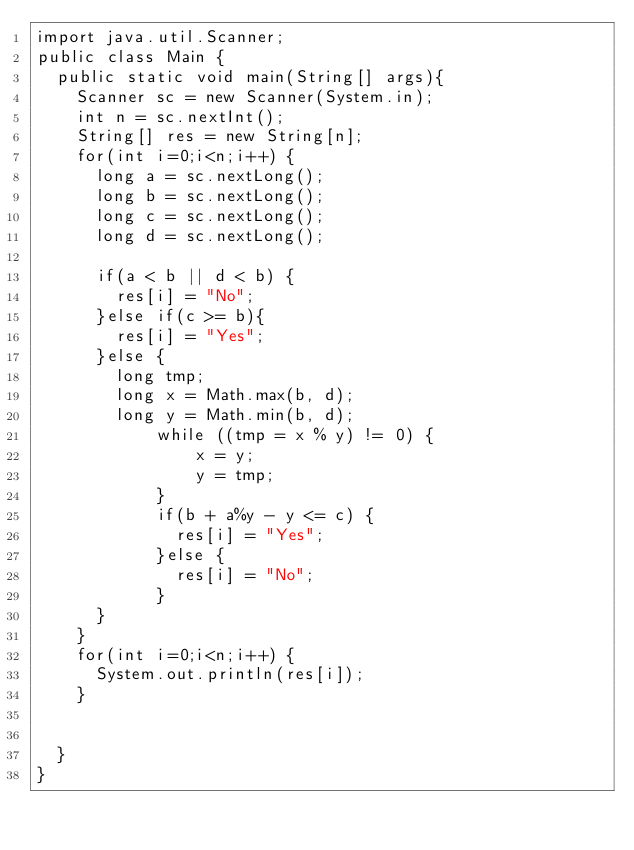<code> <loc_0><loc_0><loc_500><loc_500><_Java_>import java.util.Scanner;
public class Main {
	public static void main(String[] args){
		Scanner sc = new Scanner(System.in);
		int n = sc.nextInt();
		String[] res = new String[n];
		for(int i=0;i<n;i++) {
			long a = sc.nextLong();
			long b = sc.nextLong();
			long c = sc.nextLong();
			long d = sc.nextLong();

			if(a < b || d < b) {
				res[i] = "No";
			}else if(c >= b){
				res[i] = "Yes";
			}else {
				long tmp;
				long x = Math.max(b, d);
				long y = Math.min(b, d);
		        while ((tmp = x % y) != 0) {
		            x = y;
		            y = tmp;
		        }
		        if(b + a%y - y <= c) {
		        	res[i] = "Yes";
		        }else {
		        	res[i] = "No";
		        }
			}
		}
		for(int i=0;i<n;i++) {
			System.out.println(res[i]);
		}


	}
}</code> 